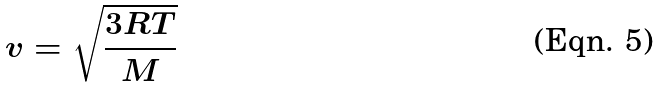<formula> <loc_0><loc_0><loc_500><loc_500>v = \sqrt { \frac { 3 R T } { M } }</formula> 